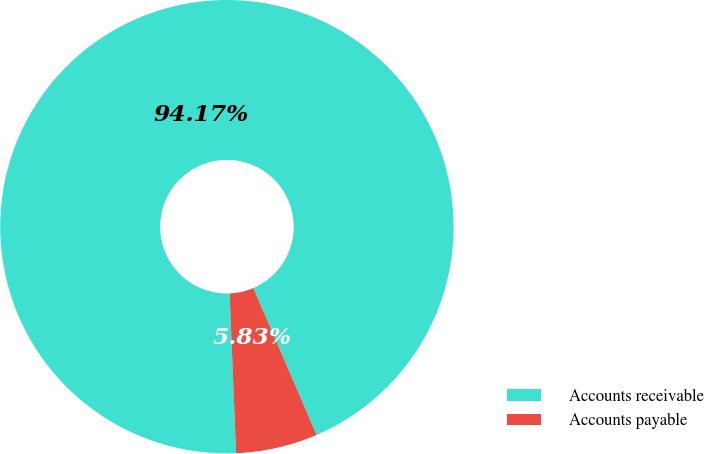<chart> <loc_0><loc_0><loc_500><loc_500><pie_chart><fcel>Accounts receivable<fcel>Accounts payable<nl><fcel>94.17%<fcel>5.83%<nl></chart> 